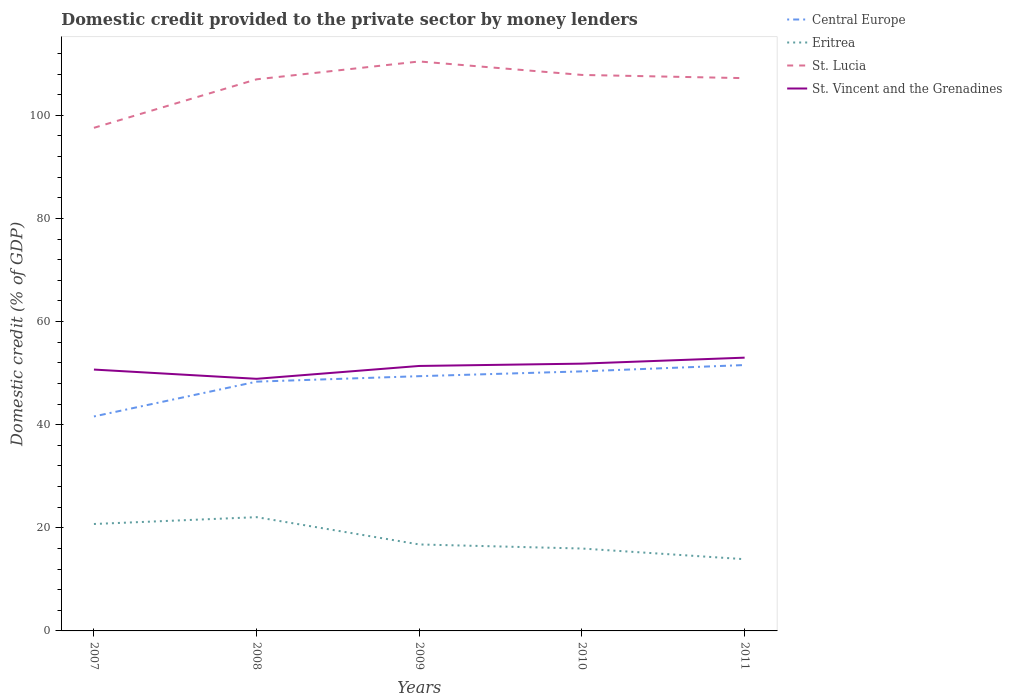How many different coloured lines are there?
Provide a short and direct response. 4. Is the number of lines equal to the number of legend labels?
Ensure brevity in your answer.  Yes. Across all years, what is the maximum domestic credit provided to the private sector by money lenders in Central Europe?
Provide a succinct answer. 41.59. What is the total domestic credit provided to the private sector by money lenders in Eritrea in the graph?
Your answer should be very brief. 5.29. What is the difference between the highest and the second highest domestic credit provided to the private sector by money lenders in St. Lucia?
Give a very brief answer. 12.87. How many years are there in the graph?
Give a very brief answer. 5. Does the graph contain grids?
Offer a very short reply. No. What is the title of the graph?
Keep it short and to the point. Domestic credit provided to the private sector by money lenders. What is the label or title of the Y-axis?
Your answer should be compact. Domestic credit (% of GDP). What is the Domestic credit (% of GDP) of Central Europe in 2007?
Offer a very short reply. 41.59. What is the Domestic credit (% of GDP) in Eritrea in 2007?
Your answer should be compact. 20.74. What is the Domestic credit (% of GDP) in St. Lucia in 2007?
Offer a terse response. 97.56. What is the Domestic credit (% of GDP) in St. Vincent and the Grenadines in 2007?
Your answer should be compact. 50.68. What is the Domestic credit (% of GDP) of Central Europe in 2008?
Offer a terse response. 48.34. What is the Domestic credit (% of GDP) in Eritrea in 2008?
Offer a very short reply. 22.06. What is the Domestic credit (% of GDP) of St. Lucia in 2008?
Make the answer very short. 106.97. What is the Domestic credit (% of GDP) of St. Vincent and the Grenadines in 2008?
Provide a succinct answer. 48.89. What is the Domestic credit (% of GDP) in Central Europe in 2009?
Make the answer very short. 49.4. What is the Domestic credit (% of GDP) in Eritrea in 2009?
Offer a very short reply. 16.77. What is the Domestic credit (% of GDP) in St. Lucia in 2009?
Your answer should be compact. 110.43. What is the Domestic credit (% of GDP) of St. Vincent and the Grenadines in 2009?
Ensure brevity in your answer.  51.38. What is the Domestic credit (% of GDP) in Central Europe in 2010?
Provide a short and direct response. 50.33. What is the Domestic credit (% of GDP) of Eritrea in 2010?
Make the answer very short. 15.98. What is the Domestic credit (% of GDP) in St. Lucia in 2010?
Your response must be concise. 107.82. What is the Domestic credit (% of GDP) of St. Vincent and the Grenadines in 2010?
Provide a succinct answer. 51.83. What is the Domestic credit (% of GDP) in Central Europe in 2011?
Provide a succinct answer. 51.56. What is the Domestic credit (% of GDP) of Eritrea in 2011?
Your answer should be compact. 13.91. What is the Domestic credit (% of GDP) of St. Lucia in 2011?
Your answer should be compact. 107.19. What is the Domestic credit (% of GDP) in St. Vincent and the Grenadines in 2011?
Give a very brief answer. 52.99. Across all years, what is the maximum Domestic credit (% of GDP) of Central Europe?
Keep it short and to the point. 51.56. Across all years, what is the maximum Domestic credit (% of GDP) of Eritrea?
Your answer should be very brief. 22.06. Across all years, what is the maximum Domestic credit (% of GDP) of St. Lucia?
Ensure brevity in your answer.  110.43. Across all years, what is the maximum Domestic credit (% of GDP) of St. Vincent and the Grenadines?
Keep it short and to the point. 52.99. Across all years, what is the minimum Domestic credit (% of GDP) in Central Europe?
Offer a terse response. 41.59. Across all years, what is the minimum Domestic credit (% of GDP) of Eritrea?
Provide a succinct answer. 13.91. Across all years, what is the minimum Domestic credit (% of GDP) in St. Lucia?
Your answer should be very brief. 97.56. Across all years, what is the minimum Domestic credit (% of GDP) of St. Vincent and the Grenadines?
Provide a succinct answer. 48.89. What is the total Domestic credit (% of GDP) in Central Europe in the graph?
Your response must be concise. 241.23. What is the total Domestic credit (% of GDP) in Eritrea in the graph?
Ensure brevity in your answer.  89.45. What is the total Domestic credit (% of GDP) in St. Lucia in the graph?
Offer a terse response. 529.98. What is the total Domestic credit (% of GDP) in St. Vincent and the Grenadines in the graph?
Provide a short and direct response. 255.78. What is the difference between the Domestic credit (% of GDP) in Central Europe in 2007 and that in 2008?
Make the answer very short. -6.75. What is the difference between the Domestic credit (% of GDP) of Eritrea in 2007 and that in 2008?
Give a very brief answer. -1.33. What is the difference between the Domestic credit (% of GDP) of St. Lucia in 2007 and that in 2008?
Make the answer very short. -9.41. What is the difference between the Domestic credit (% of GDP) in St. Vincent and the Grenadines in 2007 and that in 2008?
Offer a terse response. 1.79. What is the difference between the Domestic credit (% of GDP) of Central Europe in 2007 and that in 2009?
Ensure brevity in your answer.  -7.81. What is the difference between the Domestic credit (% of GDP) of Eritrea in 2007 and that in 2009?
Offer a terse response. 3.97. What is the difference between the Domestic credit (% of GDP) of St. Lucia in 2007 and that in 2009?
Offer a very short reply. -12.87. What is the difference between the Domestic credit (% of GDP) in St. Vincent and the Grenadines in 2007 and that in 2009?
Provide a short and direct response. -0.7. What is the difference between the Domestic credit (% of GDP) in Central Europe in 2007 and that in 2010?
Your answer should be very brief. -8.74. What is the difference between the Domestic credit (% of GDP) in Eritrea in 2007 and that in 2010?
Offer a terse response. 4.76. What is the difference between the Domestic credit (% of GDP) of St. Lucia in 2007 and that in 2010?
Ensure brevity in your answer.  -10.26. What is the difference between the Domestic credit (% of GDP) of St. Vincent and the Grenadines in 2007 and that in 2010?
Your answer should be compact. -1.15. What is the difference between the Domestic credit (% of GDP) of Central Europe in 2007 and that in 2011?
Give a very brief answer. -9.97. What is the difference between the Domestic credit (% of GDP) in Eritrea in 2007 and that in 2011?
Your answer should be compact. 6.83. What is the difference between the Domestic credit (% of GDP) of St. Lucia in 2007 and that in 2011?
Offer a terse response. -9.63. What is the difference between the Domestic credit (% of GDP) of St. Vincent and the Grenadines in 2007 and that in 2011?
Offer a very short reply. -2.31. What is the difference between the Domestic credit (% of GDP) in Central Europe in 2008 and that in 2009?
Your response must be concise. -1.06. What is the difference between the Domestic credit (% of GDP) in Eritrea in 2008 and that in 2009?
Give a very brief answer. 5.29. What is the difference between the Domestic credit (% of GDP) of St. Lucia in 2008 and that in 2009?
Ensure brevity in your answer.  -3.46. What is the difference between the Domestic credit (% of GDP) of St. Vincent and the Grenadines in 2008 and that in 2009?
Provide a succinct answer. -2.49. What is the difference between the Domestic credit (% of GDP) in Central Europe in 2008 and that in 2010?
Your answer should be very brief. -1.99. What is the difference between the Domestic credit (% of GDP) in Eritrea in 2008 and that in 2010?
Make the answer very short. 6.08. What is the difference between the Domestic credit (% of GDP) in St. Lucia in 2008 and that in 2010?
Make the answer very short. -0.85. What is the difference between the Domestic credit (% of GDP) in St. Vincent and the Grenadines in 2008 and that in 2010?
Your response must be concise. -2.94. What is the difference between the Domestic credit (% of GDP) of Central Europe in 2008 and that in 2011?
Your response must be concise. -3.22. What is the difference between the Domestic credit (% of GDP) in Eritrea in 2008 and that in 2011?
Provide a succinct answer. 8.15. What is the difference between the Domestic credit (% of GDP) of St. Lucia in 2008 and that in 2011?
Provide a succinct answer. -0.23. What is the difference between the Domestic credit (% of GDP) in St. Vincent and the Grenadines in 2008 and that in 2011?
Provide a short and direct response. -4.1. What is the difference between the Domestic credit (% of GDP) of Central Europe in 2009 and that in 2010?
Offer a very short reply. -0.93. What is the difference between the Domestic credit (% of GDP) in Eritrea in 2009 and that in 2010?
Your answer should be compact. 0.79. What is the difference between the Domestic credit (% of GDP) in St. Lucia in 2009 and that in 2010?
Offer a very short reply. 2.61. What is the difference between the Domestic credit (% of GDP) in St. Vincent and the Grenadines in 2009 and that in 2010?
Your answer should be very brief. -0.45. What is the difference between the Domestic credit (% of GDP) in Central Europe in 2009 and that in 2011?
Give a very brief answer. -2.16. What is the difference between the Domestic credit (% of GDP) in Eritrea in 2009 and that in 2011?
Make the answer very short. 2.86. What is the difference between the Domestic credit (% of GDP) in St. Lucia in 2009 and that in 2011?
Your answer should be compact. 3.24. What is the difference between the Domestic credit (% of GDP) in St. Vincent and the Grenadines in 2009 and that in 2011?
Your answer should be compact. -1.61. What is the difference between the Domestic credit (% of GDP) in Central Europe in 2010 and that in 2011?
Offer a very short reply. -1.23. What is the difference between the Domestic credit (% of GDP) in Eritrea in 2010 and that in 2011?
Ensure brevity in your answer.  2.07. What is the difference between the Domestic credit (% of GDP) in St. Lucia in 2010 and that in 2011?
Give a very brief answer. 0.62. What is the difference between the Domestic credit (% of GDP) in St. Vincent and the Grenadines in 2010 and that in 2011?
Your answer should be compact. -1.16. What is the difference between the Domestic credit (% of GDP) in Central Europe in 2007 and the Domestic credit (% of GDP) in Eritrea in 2008?
Your answer should be compact. 19.53. What is the difference between the Domestic credit (% of GDP) of Central Europe in 2007 and the Domestic credit (% of GDP) of St. Lucia in 2008?
Provide a short and direct response. -65.38. What is the difference between the Domestic credit (% of GDP) of Central Europe in 2007 and the Domestic credit (% of GDP) of St. Vincent and the Grenadines in 2008?
Your response must be concise. -7.3. What is the difference between the Domestic credit (% of GDP) of Eritrea in 2007 and the Domestic credit (% of GDP) of St. Lucia in 2008?
Your answer should be compact. -86.23. What is the difference between the Domestic credit (% of GDP) in Eritrea in 2007 and the Domestic credit (% of GDP) in St. Vincent and the Grenadines in 2008?
Your answer should be very brief. -28.15. What is the difference between the Domestic credit (% of GDP) in St. Lucia in 2007 and the Domestic credit (% of GDP) in St. Vincent and the Grenadines in 2008?
Offer a terse response. 48.67. What is the difference between the Domestic credit (% of GDP) in Central Europe in 2007 and the Domestic credit (% of GDP) in Eritrea in 2009?
Make the answer very short. 24.82. What is the difference between the Domestic credit (% of GDP) in Central Europe in 2007 and the Domestic credit (% of GDP) in St. Lucia in 2009?
Keep it short and to the point. -68.84. What is the difference between the Domestic credit (% of GDP) in Central Europe in 2007 and the Domestic credit (% of GDP) in St. Vincent and the Grenadines in 2009?
Your answer should be very brief. -9.79. What is the difference between the Domestic credit (% of GDP) in Eritrea in 2007 and the Domestic credit (% of GDP) in St. Lucia in 2009?
Make the answer very short. -89.7. What is the difference between the Domestic credit (% of GDP) in Eritrea in 2007 and the Domestic credit (% of GDP) in St. Vincent and the Grenadines in 2009?
Ensure brevity in your answer.  -30.65. What is the difference between the Domestic credit (% of GDP) in St. Lucia in 2007 and the Domestic credit (% of GDP) in St. Vincent and the Grenadines in 2009?
Your answer should be very brief. 46.18. What is the difference between the Domestic credit (% of GDP) in Central Europe in 2007 and the Domestic credit (% of GDP) in Eritrea in 2010?
Provide a succinct answer. 25.61. What is the difference between the Domestic credit (% of GDP) in Central Europe in 2007 and the Domestic credit (% of GDP) in St. Lucia in 2010?
Offer a terse response. -66.23. What is the difference between the Domestic credit (% of GDP) of Central Europe in 2007 and the Domestic credit (% of GDP) of St. Vincent and the Grenadines in 2010?
Provide a short and direct response. -10.24. What is the difference between the Domestic credit (% of GDP) of Eritrea in 2007 and the Domestic credit (% of GDP) of St. Lucia in 2010?
Provide a short and direct response. -87.08. What is the difference between the Domestic credit (% of GDP) of Eritrea in 2007 and the Domestic credit (% of GDP) of St. Vincent and the Grenadines in 2010?
Provide a short and direct response. -31.1. What is the difference between the Domestic credit (% of GDP) in St. Lucia in 2007 and the Domestic credit (% of GDP) in St. Vincent and the Grenadines in 2010?
Offer a very short reply. 45.73. What is the difference between the Domestic credit (% of GDP) in Central Europe in 2007 and the Domestic credit (% of GDP) in Eritrea in 2011?
Your answer should be very brief. 27.68. What is the difference between the Domestic credit (% of GDP) of Central Europe in 2007 and the Domestic credit (% of GDP) of St. Lucia in 2011?
Provide a succinct answer. -65.6. What is the difference between the Domestic credit (% of GDP) of Central Europe in 2007 and the Domestic credit (% of GDP) of St. Vincent and the Grenadines in 2011?
Ensure brevity in your answer.  -11.4. What is the difference between the Domestic credit (% of GDP) in Eritrea in 2007 and the Domestic credit (% of GDP) in St. Lucia in 2011?
Keep it short and to the point. -86.46. What is the difference between the Domestic credit (% of GDP) in Eritrea in 2007 and the Domestic credit (% of GDP) in St. Vincent and the Grenadines in 2011?
Your answer should be very brief. -32.26. What is the difference between the Domestic credit (% of GDP) in St. Lucia in 2007 and the Domestic credit (% of GDP) in St. Vincent and the Grenadines in 2011?
Offer a very short reply. 44.57. What is the difference between the Domestic credit (% of GDP) of Central Europe in 2008 and the Domestic credit (% of GDP) of Eritrea in 2009?
Make the answer very short. 31.57. What is the difference between the Domestic credit (% of GDP) of Central Europe in 2008 and the Domestic credit (% of GDP) of St. Lucia in 2009?
Offer a very short reply. -62.09. What is the difference between the Domestic credit (% of GDP) in Central Europe in 2008 and the Domestic credit (% of GDP) in St. Vincent and the Grenadines in 2009?
Your answer should be very brief. -3.04. What is the difference between the Domestic credit (% of GDP) of Eritrea in 2008 and the Domestic credit (% of GDP) of St. Lucia in 2009?
Provide a short and direct response. -88.37. What is the difference between the Domestic credit (% of GDP) of Eritrea in 2008 and the Domestic credit (% of GDP) of St. Vincent and the Grenadines in 2009?
Ensure brevity in your answer.  -29.32. What is the difference between the Domestic credit (% of GDP) of St. Lucia in 2008 and the Domestic credit (% of GDP) of St. Vincent and the Grenadines in 2009?
Provide a succinct answer. 55.58. What is the difference between the Domestic credit (% of GDP) in Central Europe in 2008 and the Domestic credit (% of GDP) in Eritrea in 2010?
Offer a very short reply. 32.36. What is the difference between the Domestic credit (% of GDP) of Central Europe in 2008 and the Domestic credit (% of GDP) of St. Lucia in 2010?
Give a very brief answer. -59.48. What is the difference between the Domestic credit (% of GDP) of Central Europe in 2008 and the Domestic credit (% of GDP) of St. Vincent and the Grenadines in 2010?
Your response must be concise. -3.49. What is the difference between the Domestic credit (% of GDP) in Eritrea in 2008 and the Domestic credit (% of GDP) in St. Lucia in 2010?
Give a very brief answer. -85.76. What is the difference between the Domestic credit (% of GDP) in Eritrea in 2008 and the Domestic credit (% of GDP) in St. Vincent and the Grenadines in 2010?
Give a very brief answer. -29.77. What is the difference between the Domestic credit (% of GDP) in St. Lucia in 2008 and the Domestic credit (% of GDP) in St. Vincent and the Grenadines in 2010?
Offer a very short reply. 55.14. What is the difference between the Domestic credit (% of GDP) in Central Europe in 2008 and the Domestic credit (% of GDP) in Eritrea in 2011?
Keep it short and to the point. 34.43. What is the difference between the Domestic credit (% of GDP) in Central Europe in 2008 and the Domestic credit (% of GDP) in St. Lucia in 2011?
Provide a short and direct response. -58.85. What is the difference between the Domestic credit (% of GDP) of Central Europe in 2008 and the Domestic credit (% of GDP) of St. Vincent and the Grenadines in 2011?
Your answer should be very brief. -4.65. What is the difference between the Domestic credit (% of GDP) of Eritrea in 2008 and the Domestic credit (% of GDP) of St. Lucia in 2011?
Your answer should be very brief. -85.13. What is the difference between the Domestic credit (% of GDP) in Eritrea in 2008 and the Domestic credit (% of GDP) in St. Vincent and the Grenadines in 2011?
Offer a very short reply. -30.93. What is the difference between the Domestic credit (% of GDP) in St. Lucia in 2008 and the Domestic credit (% of GDP) in St. Vincent and the Grenadines in 2011?
Offer a terse response. 53.98. What is the difference between the Domestic credit (% of GDP) of Central Europe in 2009 and the Domestic credit (% of GDP) of Eritrea in 2010?
Your response must be concise. 33.42. What is the difference between the Domestic credit (% of GDP) of Central Europe in 2009 and the Domestic credit (% of GDP) of St. Lucia in 2010?
Provide a short and direct response. -58.42. What is the difference between the Domestic credit (% of GDP) of Central Europe in 2009 and the Domestic credit (% of GDP) of St. Vincent and the Grenadines in 2010?
Your answer should be very brief. -2.43. What is the difference between the Domestic credit (% of GDP) in Eritrea in 2009 and the Domestic credit (% of GDP) in St. Lucia in 2010?
Your answer should be compact. -91.05. What is the difference between the Domestic credit (% of GDP) of Eritrea in 2009 and the Domestic credit (% of GDP) of St. Vincent and the Grenadines in 2010?
Offer a very short reply. -35.06. What is the difference between the Domestic credit (% of GDP) of St. Lucia in 2009 and the Domestic credit (% of GDP) of St. Vincent and the Grenadines in 2010?
Provide a short and direct response. 58.6. What is the difference between the Domestic credit (% of GDP) in Central Europe in 2009 and the Domestic credit (% of GDP) in Eritrea in 2011?
Your answer should be very brief. 35.49. What is the difference between the Domestic credit (% of GDP) of Central Europe in 2009 and the Domestic credit (% of GDP) of St. Lucia in 2011?
Give a very brief answer. -57.79. What is the difference between the Domestic credit (% of GDP) of Central Europe in 2009 and the Domestic credit (% of GDP) of St. Vincent and the Grenadines in 2011?
Give a very brief answer. -3.59. What is the difference between the Domestic credit (% of GDP) in Eritrea in 2009 and the Domestic credit (% of GDP) in St. Lucia in 2011?
Your response must be concise. -90.43. What is the difference between the Domestic credit (% of GDP) of Eritrea in 2009 and the Domestic credit (% of GDP) of St. Vincent and the Grenadines in 2011?
Make the answer very short. -36.22. What is the difference between the Domestic credit (% of GDP) in St. Lucia in 2009 and the Domestic credit (% of GDP) in St. Vincent and the Grenadines in 2011?
Provide a succinct answer. 57.44. What is the difference between the Domestic credit (% of GDP) of Central Europe in 2010 and the Domestic credit (% of GDP) of Eritrea in 2011?
Provide a succinct answer. 36.42. What is the difference between the Domestic credit (% of GDP) of Central Europe in 2010 and the Domestic credit (% of GDP) of St. Lucia in 2011?
Offer a terse response. -56.86. What is the difference between the Domestic credit (% of GDP) in Central Europe in 2010 and the Domestic credit (% of GDP) in St. Vincent and the Grenadines in 2011?
Provide a short and direct response. -2.66. What is the difference between the Domestic credit (% of GDP) of Eritrea in 2010 and the Domestic credit (% of GDP) of St. Lucia in 2011?
Keep it short and to the point. -91.22. What is the difference between the Domestic credit (% of GDP) of Eritrea in 2010 and the Domestic credit (% of GDP) of St. Vincent and the Grenadines in 2011?
Give a very brief answer. -37.01. What is the difference between the Domestic credit (% of GDP) of St. Lucia in 2010 and the Domestic credit (% of GDP) of St. Vincent and the Grenadines in 2011?
Offer a very short reply. 54.83. What is the average Domestic credit (% of GDP) of Central Europe per year?
Provide a short and direct response. 48.25. What is the average Domestic credit (% of GDP) in Eritrea per year?
Offer a terse response. 17.89. What is the average Domestic credit (% of GDP) of St. Lucia per year?
Offer a very short reply. 106. What is the average Domestic credit (% of GDP) in St. Vincent and the Grenadines per year?
Make the answer very short. 51.16. In the year 2007, what is the difference between the Domestic credit (% of GDP) in Central Europe and Domestic credit (% of GDP) in Eritrea?
Offer a terse response. 20.85. In the year 2007, what is the difference between the Domestic credit (% of GDP) of Central Europe and Domestic credit (% of GDP) of St. Lucia?
Your answer should be very brief. -55.97. In the year 2007, what is the difference between the Domestic credit (% of GDP) of Central Europe and Domestic credit (% of GDP) of St. Vincent and the Grenadines?
Provide a succinct answer. -9.09. In the year 2007, what is the difference between the Domestic credit (% of GDP) of Eritrea and Domestic credit (% of GDP) of St. Lucia?
Keep it short and to the point. -76.83. In the year 2007, what is the difference between the Domestic credit (% of GDP) in Eritrea and Domestic credit (% of GDP) in St. Vincent and the Grenadines?
Make the answer very short. -29.95. In the year 2007, what is the difference between the Domestic credit (% of GDP) of St. Lucia and Domestic credit (% of GDP) of St. Vincent and the Grenadines?
Offer a terse response. 46.88. In the year 2008, what is the difference between the Domestic credit (% of GDP) in Central Europe and Domestic credit (% of GDP) in Eritrea?
Keep it short and to the point. 26.28. In the year 2008, what is the difference between the Domestic credit (% of GDP) in Central Europe and Domestic credit (% of GDP) in St. Lucia?
Give a very brief answer. -58.63. In the year 2008, what is the difference between the Domestic credit (% of GDP) in Central Europe and Domestic credit (% of GDP) in St. Vincent and the Grenadines?
Ensure brevity in your answer.  -0.55. In the year 2008, what is the difference between the Domestic credit (% of GDP) in Eritrea and Domestic credit (% of GDP) in St. Lucia?
Make the answer very short. -84.91. In the year 2008, what is the difference between the Domestic credit (% of GDP) in Eritrea and Domestic credit (% of GDP) in St. Vincent and the Grenadines?
Ensure brevity in your answer.  -26.83. In the year 2008, what is the difference between the Domestic credit (% of GDP) in St. Lucia and Domestic credit (% of GDP) in St. Vincent and the Grenadines?
Your answer should be very brief. 58.08. In the year 2009, what is the difference between the Domestic credit (% of GDP) of Central Europe and Domestic credit (% of GDP) of Eritrea?
Make the answer very short. 32.63. In the year 2009, what is the difference between the Domestic credit (% of GDP) of Central Europe and Domestic credit (% of GDP) of St. Lucia?
Provide a succinct answer. -61.03. In the year 2009, what is the difference between the Domestic credit (% of GDP) of Central Europe and Domestic credit (% of GDP) of St. Vincent and the Grenadines?
Provide a succinct answer. -1.98. In the year 2009, what is the difference between the Domestic credit (% of GDP) in Eritrea and Domestic credit (% of GDP) in St. Lucia?
Your answer should be compact. -93.66. In the year 2009, what is the difference between the Domestic credit (% of GDP) of Eritrea and Domestic credit (% of GDP) of St. Vincent and the Grenadines?
Make the answer very short. -34.62. In the year 2009, what is the difference between the Domestic credit (% of GDP) in St. Lucia and Domestic credit (% of GDP) in St. Vincent and the Grenadines?
Make the answer very short. 59.05. In the year 2010, what is the difference between the Domestic credit (% of GDP) of Central Europe and Domestic credit (% of GDP) of Eritrea?
Keep it short and to the point. 34.35. In the year 2010, what is the difference between the Domestic credit (% of GDP) of Central Europe and Domestic credit (% of GDP) of St. Lucia?
Make the answer very short. -57.49. In the year 2010, what is the difference between the Domestic credit (% of GDP) in Central Europe and Domestic credit (% of GDP) in St. Vincent and the Grenadines?
Ensure brevity in your answer.  -1.5. In the year 2010, what is the difference between the Domestic credit (% of GDP) of Eritrea and Domestic credit (% of GDP) of St. Lucia?
Your answer should be very brief. -91.84. In the year 2010, what is the difference between the Domestic credit (% of GDP) in Eritrea and Domestic credit (% of GDP) in St. Vincent and the Grenadines?
Your answer should be very brief. -35.85. In the year 2010, what is the difference between the Domestic credit (% of GDP) of St. Lucia and Domestic credit (% of GDP) of St. Vincent and the Grenadines?
Your answer should be very brief. 55.99. In the year 2011, what is the difference between the Domestic credit (% of GDP) of Central Europe and Domestic credit (% of GDP) of Eritrea?
Keep it short and to the point. 37.65. In the year 2011, what is the difference between the Domestic credit (% of GDP) of Central Europe and Domestic credit (% of GDP) of St. Lucia?
Provide a succinct answer. -55.63. In the year 2011, what is the difference between the Domestic credit (% of GDP) of Central Europe and Domestic credit (% of GDP) of St. Vincent and the Grenadines?
Keep it short and to the point. -1.43. In the year 2011, what is the difference between the Domestic credit (% of GDP) in Eritrea and Domestic credit (% of GDP) in St. Lucia?
Keep it short and to the point. -93.29. In the year 2011, what is the difference between the Domestic credit (% of GDP) of Eritrea and Domestic credit (% of GDP) of St. Vincent and the Grenadines?
Offer a terse response. -39.08. In the year 2011, what is the difference between the Domestic credit (% of GDP) of St. Lucia and Domestic credit (% of GDP) of St. Vincent and the Grenadines?
Give a very brief answer. 54.2. What is the ratio of the Domestic credit (% of GDP) in Central Europe in 2007 to that in 2008?
Provide a short and direct response. 0.86. What is the ratio of the Domestic credit (% of GDP) of Eritrea in 2007 to that in 2008?
Make the answer very short. 0.94. What is the ratio of the Domestic credit (% of GDP) in St. Lucia in 2007 to that in 2008?
Your response must be concise. 0.91. What is the ratio of the Domestic credit (% of GDP) in St. Vincent and the Grenadines in 2007 to that in 2008?
Keep it short and to the point. 1.04. What is the ratio of the Domestic credit (% of GDP) of Central Europe in 2007 to that in 2009?
Offer a terse response. 0.84. What is the ratio of the Domestic credit (% of GDP) of Eritrea in 2007 to that in 2009?
Offer a terse response. 1.24. What is the ratio of the Domestic credit (% of GDP) in St. Lucia in 2007 to that in 2009?
Make the answer very short. 0.88. What is the ratio of the Domestic credit (% of GDP) in St. Vincent and the Grenadines in 2007 to that in 2009?
Provide a short and direct response. 0.99. What is the ratio of the Domestic credit (% of GDP) of Central Europe in 2007 to that in 2010?
Your answer should be very brief. 0.83. What is the ratio of the Domestic credit (% of GDP) of Eritrea in 2007 to that in 2010?
Ensure brevity in your answer.  1.3. What is the ratio of the Domestic credit (% of GDP) in St. Lucia in 2007 to that in 2010?
Provide a short and direct response. 0.9. What is the ratio of the Domestic credit (% of GDP) in St. Vincent and the Grenadines in 2007 to that in 2010?
Your answer should be compact. 0.98. What is the ratio of the Domestic credit (% of GDP) in Central Europe in 2007 to that in 2011?
Your response must be concise. 0.81. What is the ratio of the Domestic credit (% of GDP) of Eritrea in 2007 to that in 2011?
Make the answer very short. 1.49. What is the ratio of the Domestic credit (% of GDP) of St. Lucia in 2007 to that in 2011?
Give a very brief answer. 0.91. What is the ratio of the Domestic credit (% of GDP) in St. Vincent and the Grenadines in 2007 to that in 2011?
Offer a terse response. 0.96. What is the ratio of the Domestic credit (% of GDP) of Central Europe in 2008 to that in 2009?
Your response must be concise. 0.98. What is the ratio of the Domestic credit (% of GDP) of Eritrea in 2008 to that in 2009?
Make the answer very short. 1.32. What is the ratio of the Domestic credit (% of GDP) in St. Lucia in 2008 to that in 2009?
Your response must be concise. 0.97. What is the ratio of the Domestic credit (% of GDP) of St. Vincent and the Grenadines in 2008 to that in 2009?
Your answer should be compact. 0.95. What is the ratio of the Domestic credit (% of GDP) of Central Europe in 2008 to that in 2010?
Provide a short and direct response. 0.96. What is the ratio of the Domestic credit (% of GDP) of Eritrea in 2008 to that in 2010?
Offer a terse response. 1.38. What is the ratio of the Domestic credit (% of GDP) of St. Vincent and the Grenadines in 2008 to that in 2010?
Your answer should be compact. 0.94. What is the ratio of the Domestic credit (% of GDP) of Central Europe in 2008 to that in 2011?
Provide a succinct answer. 0.94. What is the ratio of the Domestic credit (% of GDP) in Eritrea in 2008 to that in 2011?
Your answer should be very brief. 1.59. What is the ratio of the Domestic credit (% of GDP) of St. Vincent and the Grenadines in 2008 to that in 2011?
Give a very brief answer. 0.92. What is the ratio of the Domestic credit (% of GDP) in Central Europe in 2009 to that in 2010?
Ensure brevity in your answer.  0.98. What is the ratio of the Domestic credit (% of GDP) in Eritrea in 2009 to that in 2010?
Offer a very short reply. 1.05. What is the ratio of the Domestic credit (% of GDP) in St. Lucia in 2009 to that in 2010?
Give a very brief answer. 1.02. What is the ratio of the Domestic credit (% of GDP) in Central Europe in 2009 to that in 2011?
Your answer should be compact. 0.96. What is the ratio of the Domestic credit (% of GDP) of Eritrea in 2009 to that in 2011?
Ensure brevity in your answer.  1.21. What is the ratio of the Domestic credit (% of GDP) in St. Lucia in 2009 to that in 2011?
Provide a succinct answer. 1.03. What is the ratio of the Domestic credit (% of GDP) of St. Vincent and the Grenadines in 2009 to that in 2011?
Your response must be concise. 0.97. What is the ratio of the Domestic credit (% of GDP) in Central Europe in 2010 to that in 2011?
Offer a very short reply. 0.98. What is the ratio of the Domestic credit (% of GDP) in Eritrea in 2010 to that in 2011?
Make the answer very short. 1.15. What is the ratio of the Domestic credit (% of GDP) in St. Lucia in 2010 to that in 2011?
Provide a succinct answer. 1.01. What is the ratio of the Domestic credit (% of GDP) in St. Vincent and the Grenadines in 2010 to that in 2011?
Provide a succinct answer. 0.98. What is the difference between the highest and the second highest Domestic credit (% of GDP) of Central Europe?
Offer a very short reply. 1.23. What is the difference between the highest and the second highest Domestic credit (% of GDP) of Eritrea?
Offer a terse response. 1.33. What is the difference between the highest and the second highest Domestic credit (% of GDP) in St. Lucia?
Ensure brevity in your answer.  2.61. What is the difference between the highest and the second highest Domestic credit (% of GDP) in St. Vincent and the Grenadines?
Your answer should be compact. 1.16. What is the difference between the highest and the lowest Domestic credit (% of GDP) of Central Europe?
Offer a terse response. 9.97. What is the difference between the highest and the lowest Domestic credit (% of GDP) in Eritrea?
Provide a short and direct response. 8.15. What is the difference between the highest and the lowest Domestic credit (% of GDP) of St. Lucia?
Ensure brevity in your answer.  12.87. What is the difference between the highest and the lowest Domestic credit (% of GDP) in St. Vincent and the Grenadines?
Your answer should be very brief. 4.1. 